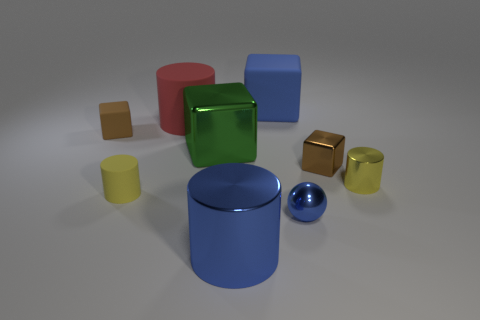The big metal cylinder is what color?
Your answer should be very brief. Blue. Is there any other thing that has the same shape as the small blue thing?
Provide a succinct answer. No. The large metal object that is the same shape as the large red rubber object is what color?
Ensure brevity in your answer.  Blue. Do the green thing and the brown matte thing have the same shape?
Provide a succinct answer. Yes. What number of cylinders are either small brown things or large green objects?
Your answer should be very brief. 0. The large block that is the same material as the ball is what color?
Ensure brevity in your answer.  Green. There is a brown thing behind the green object; does it have the same size as the green metallic object?
Provide a short and direct response. No. Is the tiny blue sphere made of the same material as the brown cube to the left of the big red cylinder?
Provide a succinct answer. No. The shiny cube that is to the right of the tiny blue metal ball is what color?
Your answer should be compact. Brown. Are there any yellow rubber things behind the big cylinder behind the tiny brown rubber cube?
Give a very brief answer. No. 